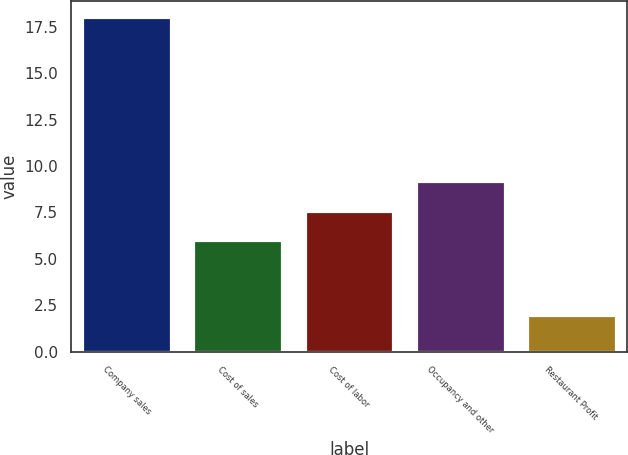Convert chart. <chart><loc_0><loc_0><loc_500><loc_500><bar_chart><fcel>Company sales<fcel>Cost of sales<fcel>Cost of labor<fcel>Occupancy and other<fcel>Restaurant Profit<nl><fcel>18<fcel>6<fcel>7.6<fcel>9.2<fcel>2<nl></chart> 